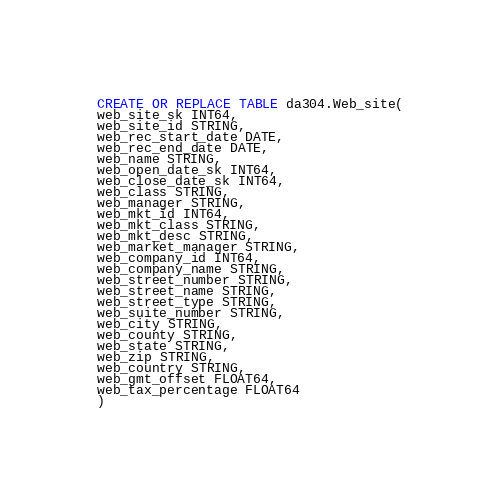<code> <loc_0><loc_0><loc_500><loc_500><_SQL_>CREATE OR REPLACE TABLE da304.Web_site(
web_site_sk INT64,
web_site_id STRING,
web_rec_start_date DATE,
web_rec_end_date DATE,
web_name STRING,
web_open_date_sk INT64,
web_close_date_sk INT64,
web_class STRING,
web_manager STRING,
web_mkt_id INT64,
web_mkt_class STRING,
web_mkt_desc STRING,
web_market_manager STRING,
web_company_id INT64,
web_company_name STRING,
web_street_number STRING,
web_street_name STRING,
web_street_type STRING,
web_suite_number STRING,
web_city STRING,
web_county STRING,
web_state STRING,
web_zip STRING,
web_country STRING,
web_gmt_offset FLOAT64,
web_tax_percentage FLOAT64
)
</code> 